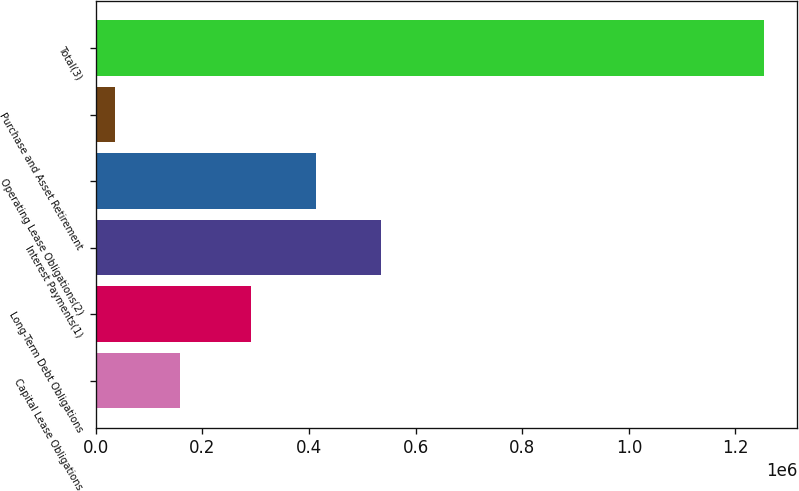Convert chart. <chart><loc_0><loc_0><loc_500><loc_500><bar_chart><fcel>Capital Lease Obligations<fcel>Long-Term Debt Obligations<fcel>Interest Payments(1)<fcel>Operating Lease Obligations(2)<fcel>Purchase and Asset Retirement<fcel>Total(3)<nl><fcel>158064<fcel>290854<fcel>534304<fcel>412579<fcel>36339<fcel>1.25359e+06<nl></chart> 